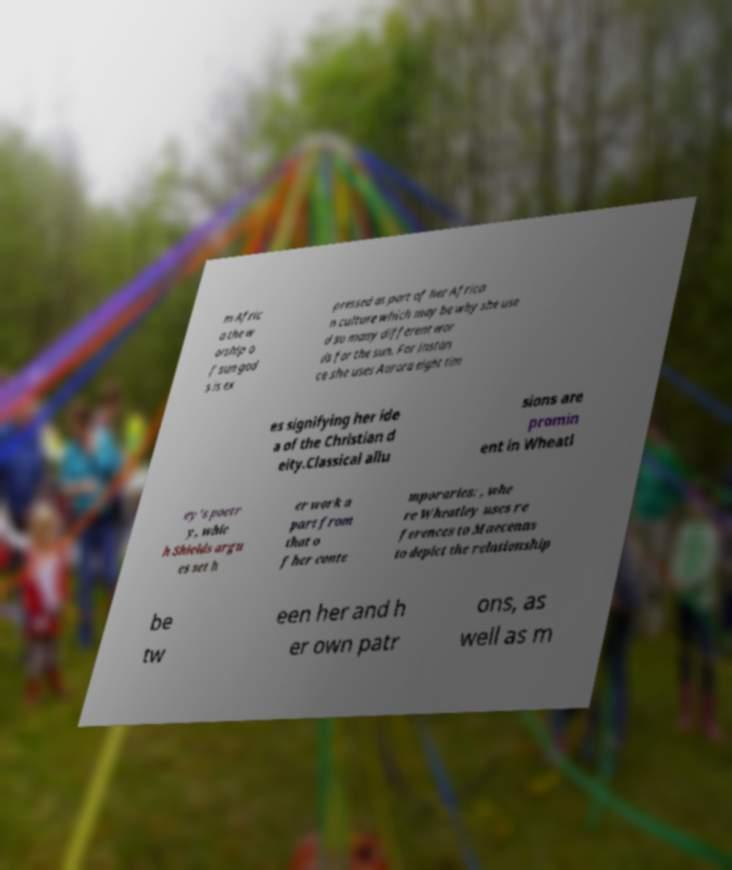Please identify and transcribe the text found in this image. m Afric a the w orship o f sun god s is ex pressed as part of her Africa n culture which may be why she use d so many different wor ds for the sun. For instan ce she uses Aurora eight tim es signifying her ide a of the Christian d eity.Classical allu sions are promin ent in Wheatl ey's poetr y, whic h Shields argu es set h er work a part from that o f her conte mporaries: , whe re Wheatley uses re ferences to Maecenas to depict the relationship be tw een her and h er own patr ons, as well as m 